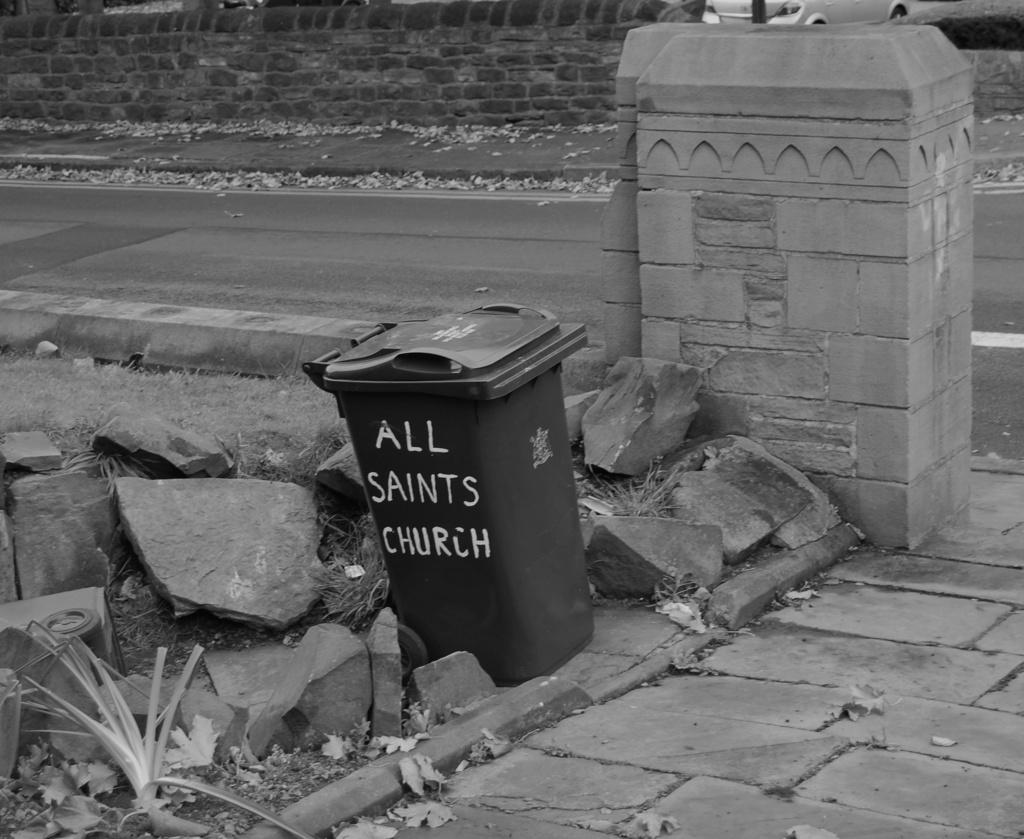Provide a one-sentence caption for the provided image. A garbage can sits on a curb from All Saints Church. 